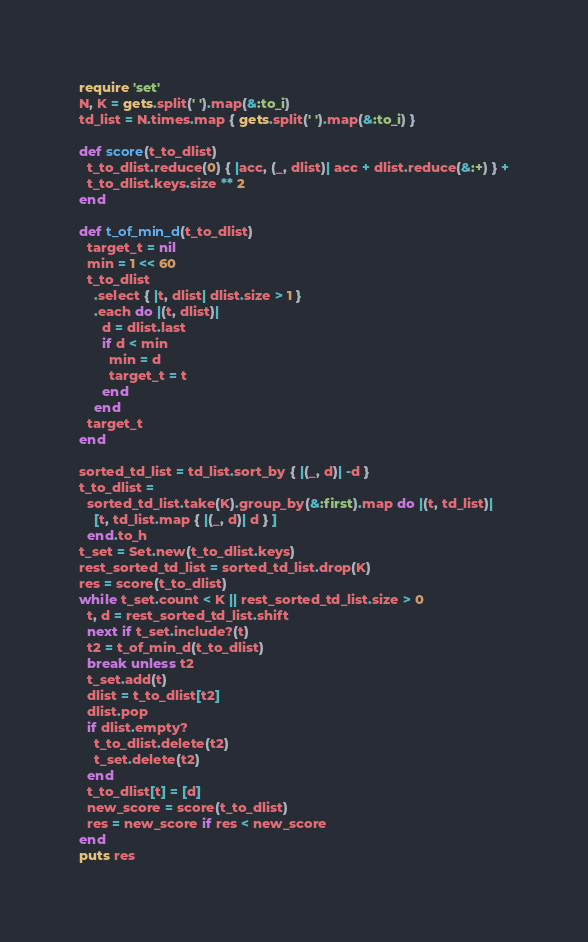<code> <loc_0><loc_0><loc_500><loc_500><_Ruby_>require 'set'
N, K = gets.split(' ').map(&:to_i)
td_list = N.times.map { gets.split(' ').map(&:to_i) }

def score(t_to_dlist)
  t_to_dlist.reduce(0) { |acc, (_, dlist)| acc + dlist.reduce(&:+) } +
  t_to_dlist.keys.size ** 2
end

def t_of_min_d(t_to_dlist)
  target_t = nil
  min = 1 << 60
  t_to_dlist
    .select { |t, dlist| dlist.size > 1 }
    .each do |(t, dlist)|
      d = dlist.last
      if d < min
        min = d
        target_t = t
      end
    end
  target_t
end

sorted_td_list = td_list.sort_by { |(_, d)| -d }
t_to_dlist =
  sorted_td_list.take(K).group_by(&:first).map do |(t, td_list)|
    [t, td_list.map { |(_, d)| d } ]
  end.to_h
t_set = Set.new(t_to_dlist.keys)
rest_sorted_td_list = sorted_td_list.drop(K)
res = score(t_to_dlist)
while t_set.count < K || rest_sorted_td_list.size > 0
  t, d = rest_sorted_td_list.shift
  next if t_set.include?(t)
  t2 = t_of_min_d(t_to_dlist)
  break unless t2
  t_set.add(t)
  dlist = t_to_dlist[t2]
  dlist.pop
  if dlist.empty?
    t_to_dlist.delete(t2)
    t_set.delete(t2)
  end
  t_to_dlist[t] = [d]
  new_score = score(t_to_dlist)
  res = new_score if res < new_score
end
puts res
</code> 